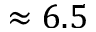Convert formula to latex. <formula><loc_0><loc_0><loc_500><loc_500>\approx 6 . 5</formula> 